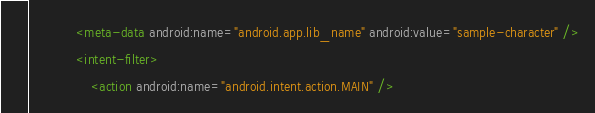<code> <loc_0><loc_0><loc_500><loc_500><_XML_>            <meta-data android:name="android.app.lib_name" android:value="sample-character" />
            <intent-filter>
                <action android:name="android.intent.action.MAIN" /></code> 